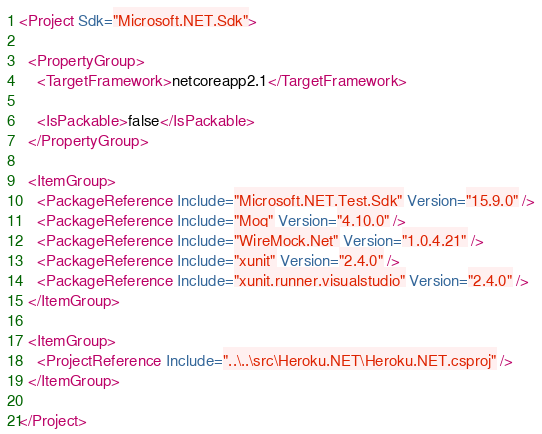Convert code to text. <code><loc_0><loc_0><loc_500><loc_500><_XML_><Project Sdk="Microsoft.NET.Sdk">

  <PropertyGroup>
    <TargetFramework>netcoreapp2.1</TargetFramework>

    <IsPackable>false</IsPackable>
  </PropertyGroup>

  <ItemGroup>
    <PackageReference Include="Microsoft.NET.Test.Sdk" Version="15.9.0" />
    <PackageReference Include="Moq" Version="4.10.0" />
    <PackageReference Include="WireMock.Net" Version="1.0.4.21" />
    <PackageReference Include="xunit" Version="2.4.0" />
    <PackageReference Include="xunit.runner.visualstudio" Version="2.4.0" />
  </ItemGroup>

  <ItemGroup>
    <ProjectReference Include="..\..\src\Heroku.NET\Heroku.NET.csproj" />
  </ItemGroup>

</Project>
</code> 